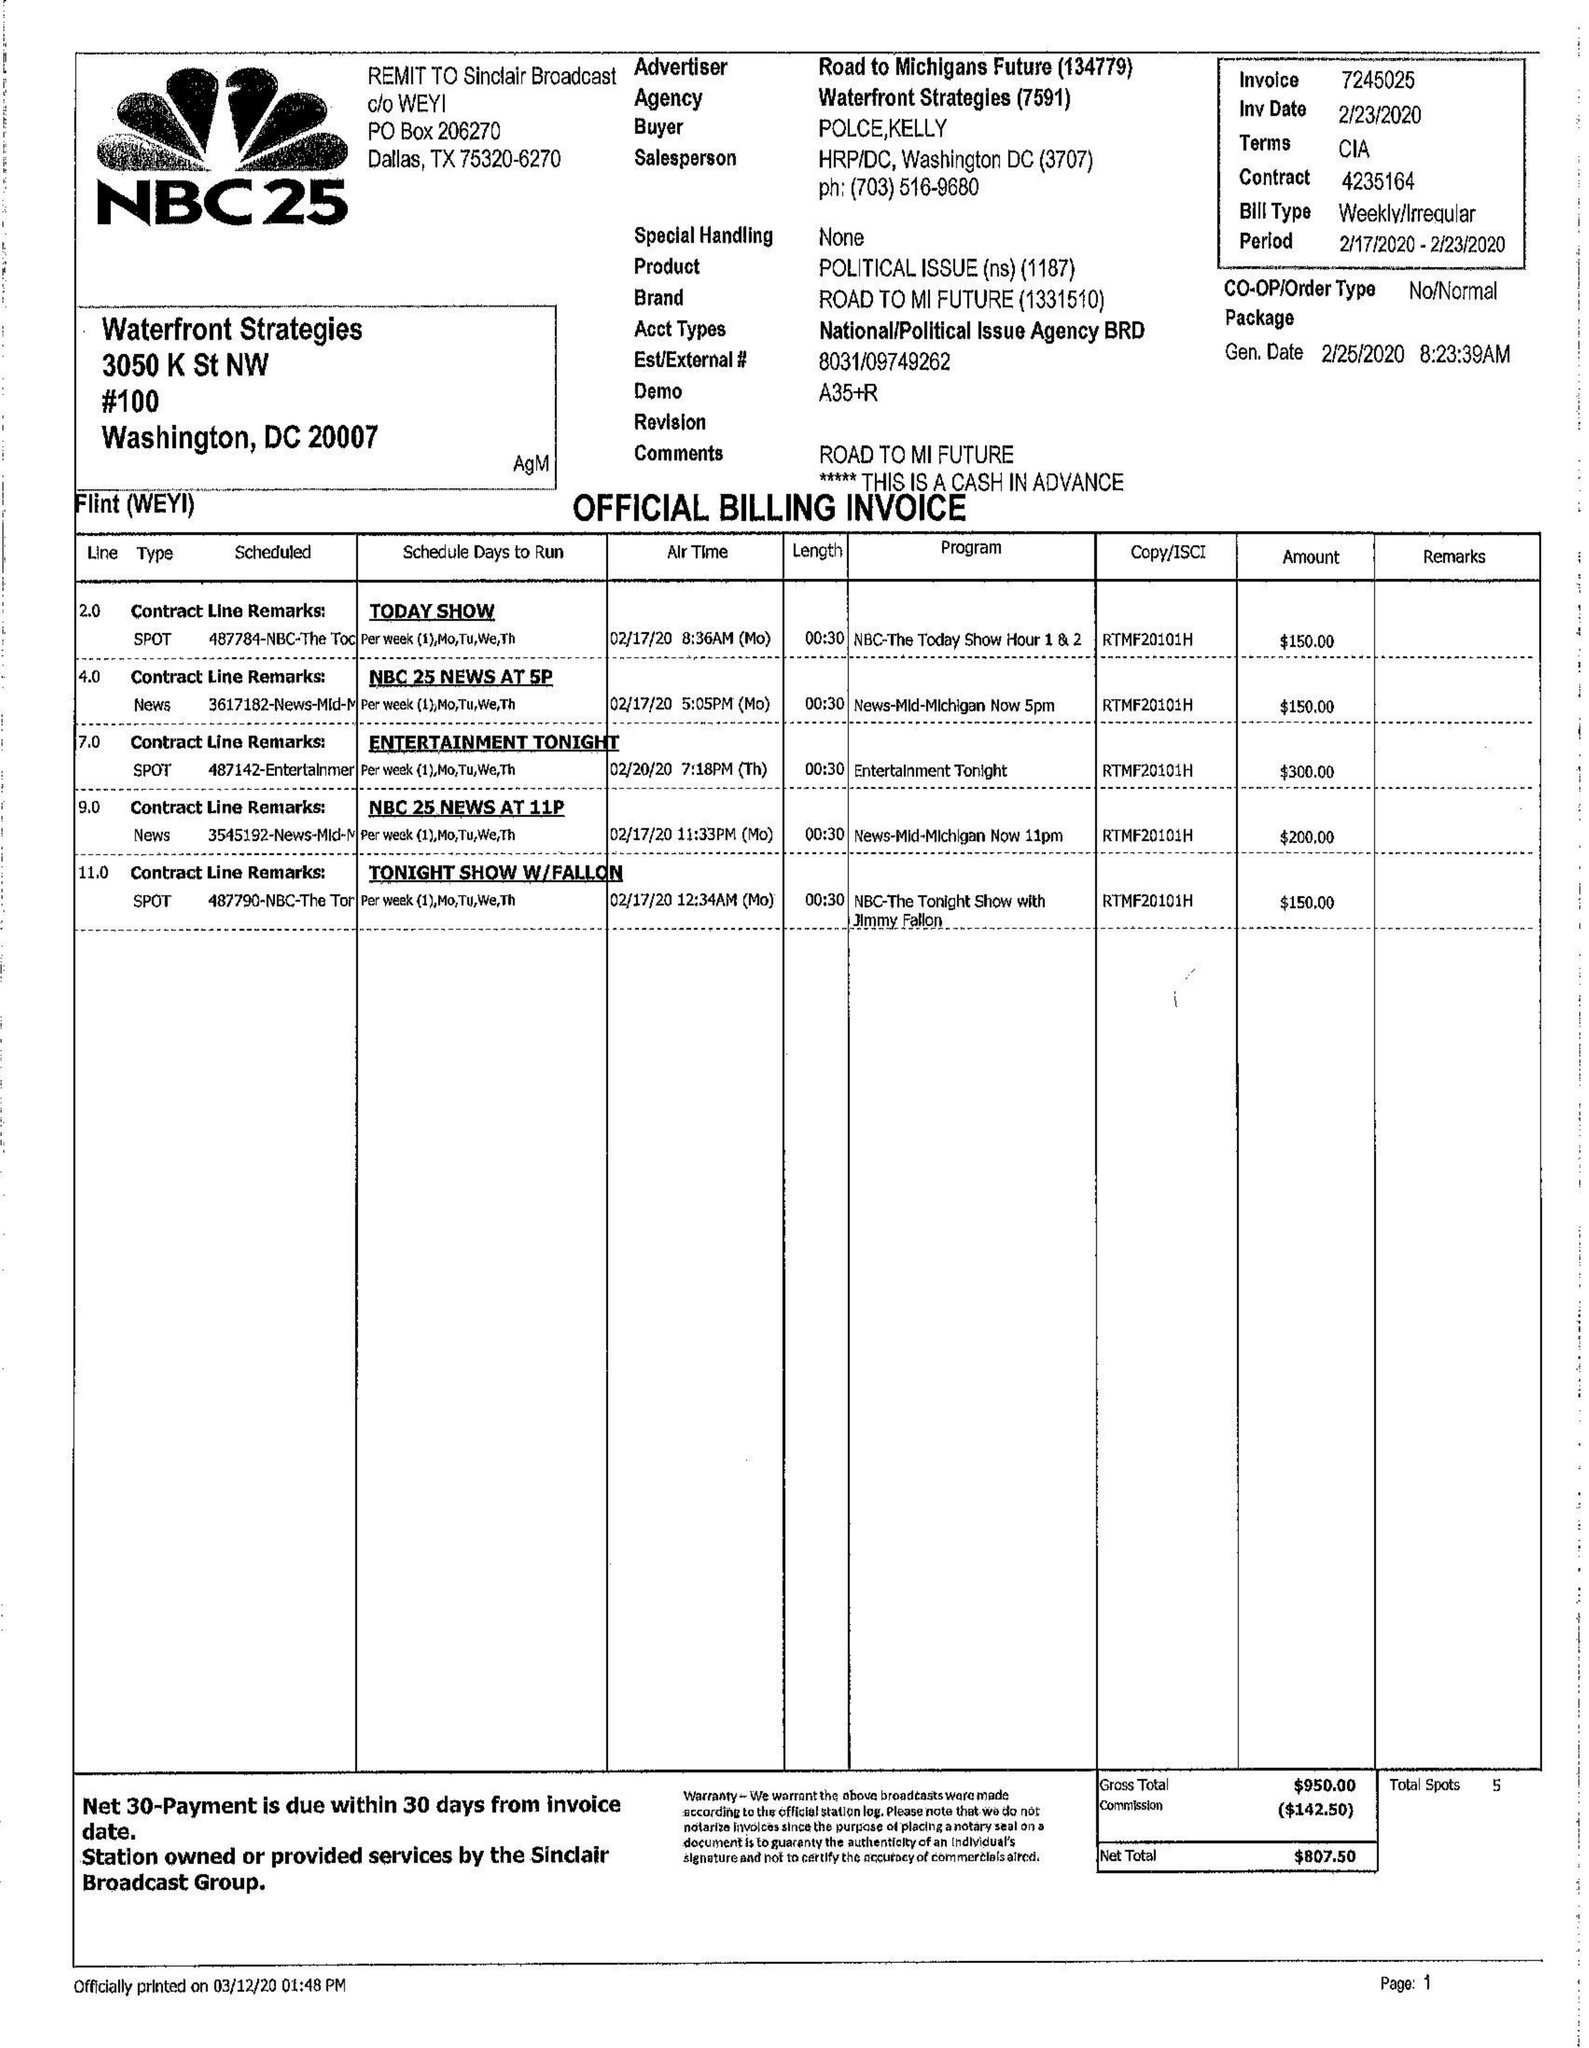What is the value for the flight_to?
Answer the question using a single word or phrase. 02/23/20 